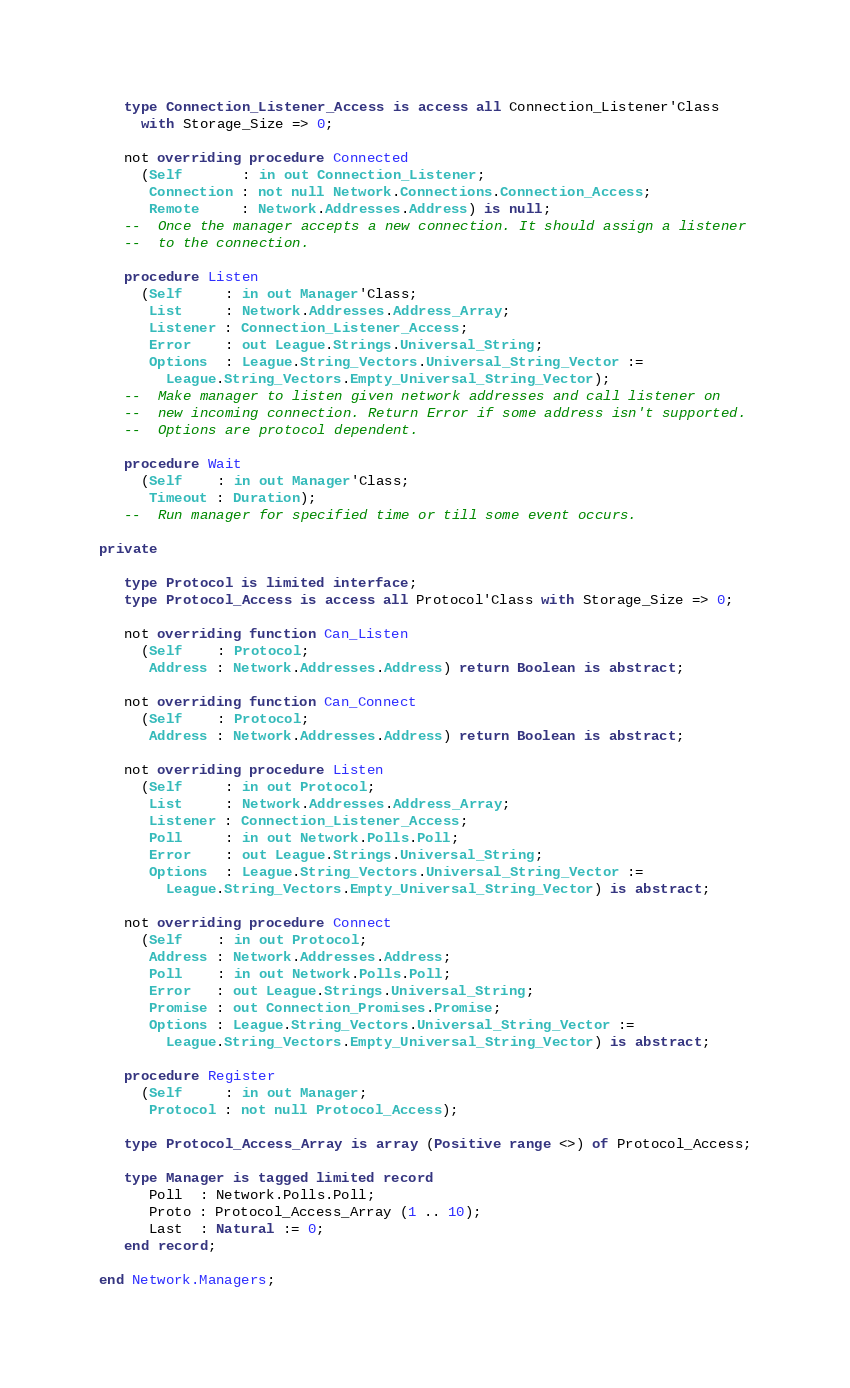Convert code to text. <code><loc_0><loc_0><loc_500><loc_500><_Ada_>   type Connection_Listener_Access is access all Connection_Listener'Class
     with Storage_Size => 0;

   not overriding procedure Connected
     (Self       : in out Connection_Listener;
      Connection : not null Network.Connections.Connection_Access;
      Remote     : Network.Addresses.Address) is null;
   --  Once the manager accepts a new connection. It should assign a listener
   --  to the connection.

   procedure Listen
     (Self     : in out Manager'Class;
      List     : Network.Addresses.Address_Array;
      Listener : Connection_Listener_Access;
      Error    : out League.Strings.Universal_String;
      Options  : League.String_Vectors.Universal_String_Vector :=
        League.String_Vectors.Empty_Universal_String_Vector);
   --  Make manager to listen given network addresses and call listener on
   --  new incoming connection. Return Error if some address isn't supported.
   --  Options are protocol dependent.

   procedure Wait
     (Self    : in out Manager'Class;
      Timeout : Duration);
   --  Run manager for specified time or till some event occurs.

private

   type Protocol is limited interface;
   type Protocol_Access is access all Protocol'Class with Storage_Size => 0;

   not overriding function Can_Listen
     (Self    : Protocol;
      Address : Network.Addresses.Address) return Boolean is abstract;

   not overriding function Can_Connect
     (Self    : Protocol;
      Address : Network.Addresses.Address) return Boolean is abstract;

   not overriding procedure Listen
     (Self     : in out Protocol;
      List     : Network.Addresses.Address_Array;
      Listener : Connection_Listener_Access;
      Poll     : in out Network.Polls.Poll;
      Error    : out League.Strings.Universal_String;
      Options  : League.String_Vectors.Universal_String_Vector :=
        League.String_Vectors.Empty_Universal_String_Vector) is abstract;

   not overriding procedure Connect
     (Self    : in out Protocol;
      Address : Network.Addresses.Address;
      Poll    : in out Network.Polls.Poll;
      Error   : out League.Strings.Universal_String;
      Promise : out Connection_Promises.Promise;
      Options : League.String_Vectors.Universal_String_Vector :=
        League.String_Vectors.Empty_Universal_String_Vector) is abstract;

   procedure Register
     (Self     : in out Manager;
      Protocol : not null Protocol_Access);

   type Protocol_Access_Array is array (Positive range <>) of Protocol_Access;

   type Manager is tagged limited record
      Poll  : Network.Polls.Poll;
      Proto : Protocol_Access_Array (1 .. 10);
      Last  : Natural := 0;
   end record;

end Network.Managers;
</code> 